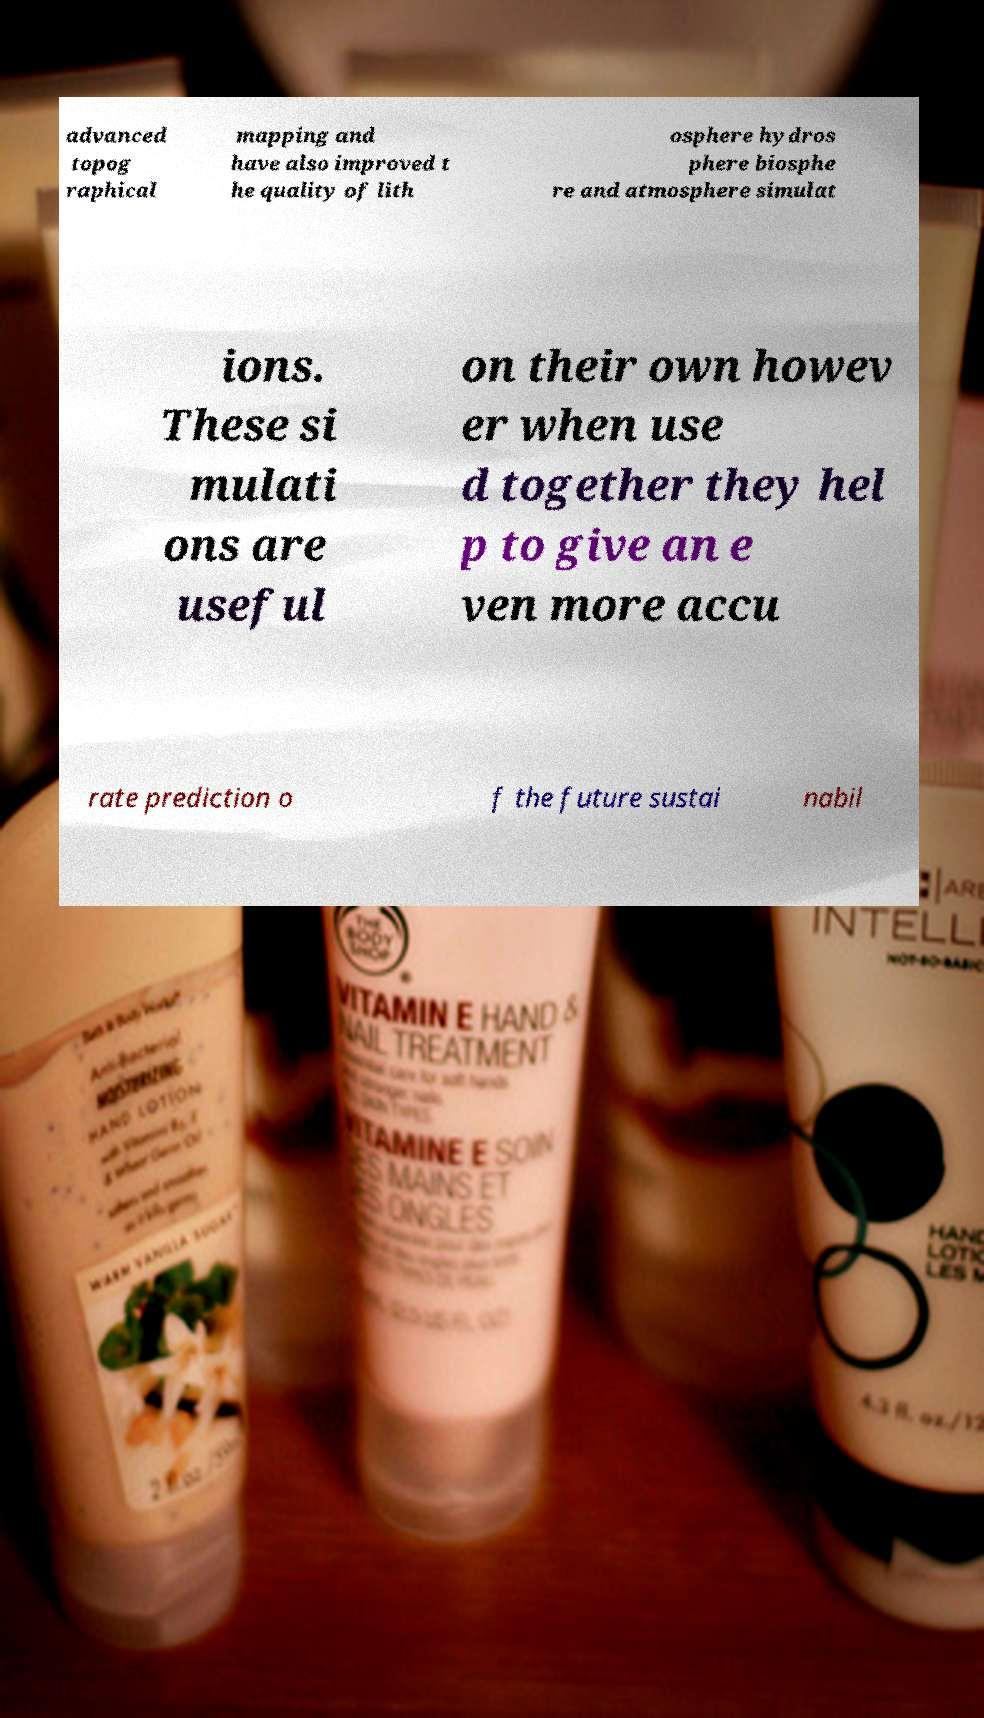Please read and relay the text visible in this image. What does it say? advanced topog raphical mapping and have also improved t he quality of lith osphere hydros phere biosphe re and atmosphere simulat ions. These si mulati ons are useful on their own howev er when use d together they hel p to give an e ven more accu rate prediction o f the future sustai nabil 